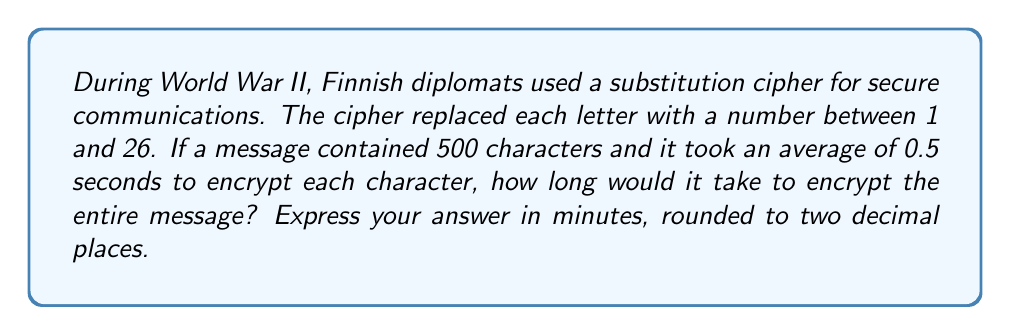Can you answer this question? To solve this problem, we need to follow these steps:

1. Determine the total time needed to encrypt all characters:
   Let $t$ be the time to encrypt one character, and $n$ be the number of characters.
   Total time $T = t \times n$
   $T = 0.5 \text{ seconds} \times 500 = 250 \text{ seconds}$

2. Convert seconds to minutes:
   $$\text{Time in minutes} = \frac{\text{Time in seconds}}{60}$$
   $$\text{Time in minutes} = \frac{250}{60} = 4.1666... \text{ minutes}$$

3. Round the result to two decimal places:
   $4.1666...$ rounded to two decimal places is $4.17$ minutes.

This calculation provides insight into the time efficiency of the encryption process used by Finnish diplomats during World War II, which is relevant to understanding the operational aspects of Finnish diplomatic communications in that period.
Answer: 4.17 minutes 